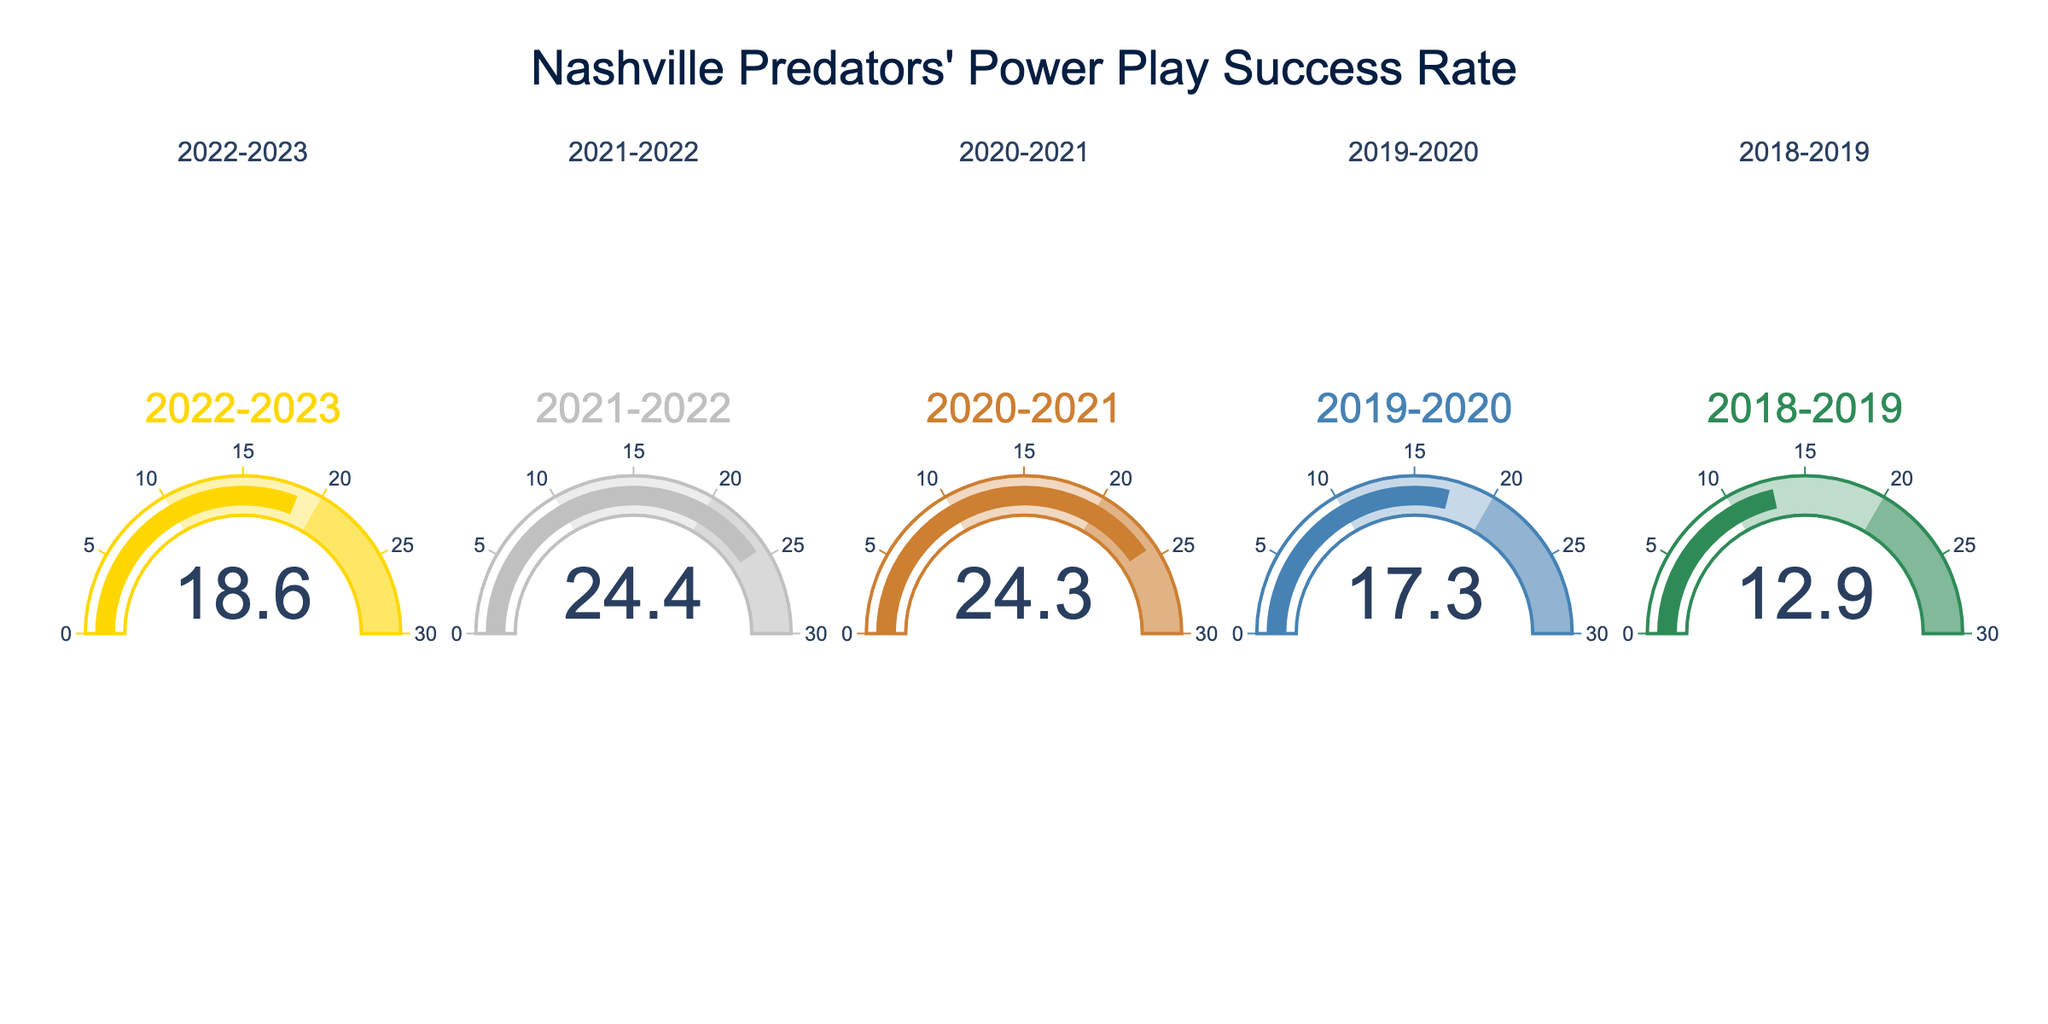What is the Power Play success rate for the 2022-2023 season? Look at the gauge chart labeled "2022-2023" in the figure to find the percentage displayed.
Answer: 18.6% Which season had the highest Power Play success rate? Compare the values on all the gauge charts; the highest value is the highest success rate.
Answer: 2021-2022 What is the difference in Power Play success rate between the 2021-2022 and 2018-2019 seasons? Subtract the 2018-2019 value from the 2021-2022 value: 24.4% - 12.9% = 11.5%
Answer: 11.5% Which season had the lowest Power Play success rate? Compare the values on all gauge charts; the lowest value is the lowest success rate.
Answer: 2018-2019 What is the average Power Play success rate over the given seasons? Add all the percentages together and divide by the number of seasons: (18.6 + 24.4 + 24.3 + 17.3 + 12.9) / 5 = 19.5%
Answer: 19.5% In how many seasons did the Power Play success rate exceed 20%? Count how many seasons have values above 20% on the gauge charts.
Answer: 2 seasons Between which consecutive seasons did the Power Play success rate improve the most significantly? Calculate the differences between consecutive seasons and identify the largest positive difference: (24.4 - 18.6), (24.3 - 24.4), (17.3 - 24.3), (12.9 - 17.3). The largest positive difference is between 2018-2019 and 2019-2020.
Answer: 2018-2019 and 2019-2020 What is the median Power Play success rate across the seasons shown? Arrange the values in ascending order (12.9, 17.3, 18.6, 24.3, 24.4), and find the middle value, which is the median.
Answer: 18.6% Which season saw an improvement in Power Play success rate compared to the previous season? Check each season's value and compare it with the previous season’s value to see if there is an increase. The 2018-2019 rate of 12.9%, the next season 2019-2020 is 17.3%, showing improvement.
Answer: 2019-2020 